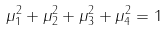<formula> <loc_0><loc_0><loc_500><loc_500>\mu _ { 1 } ^ { 2 } + \mu _ { 2 } ^ { 2 } + \mu _ { 3 } ^ { 2 } + \mu _ { 4 } ^ { 2 } = 1</formula> 